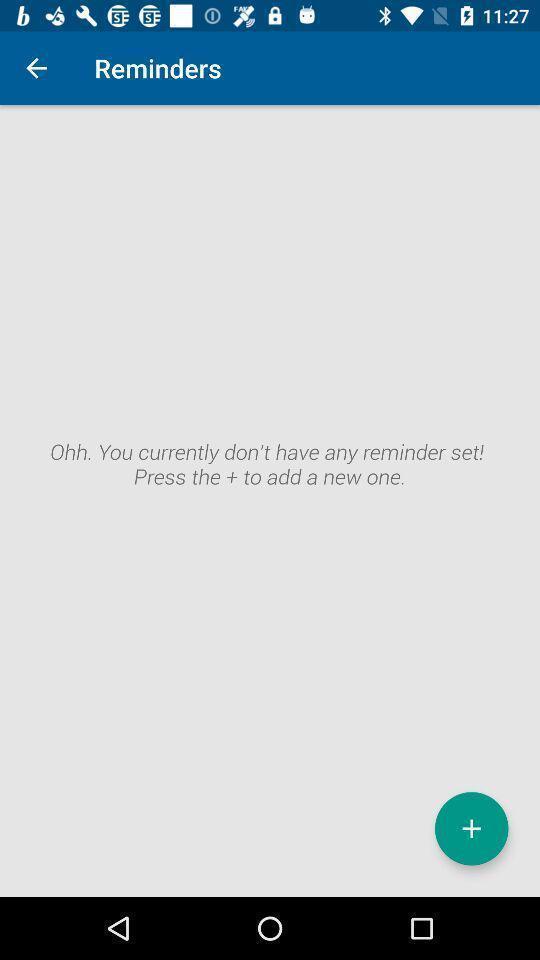Provide a detailed account of this screenshot. Screen displaying controls and results in an alert page. 